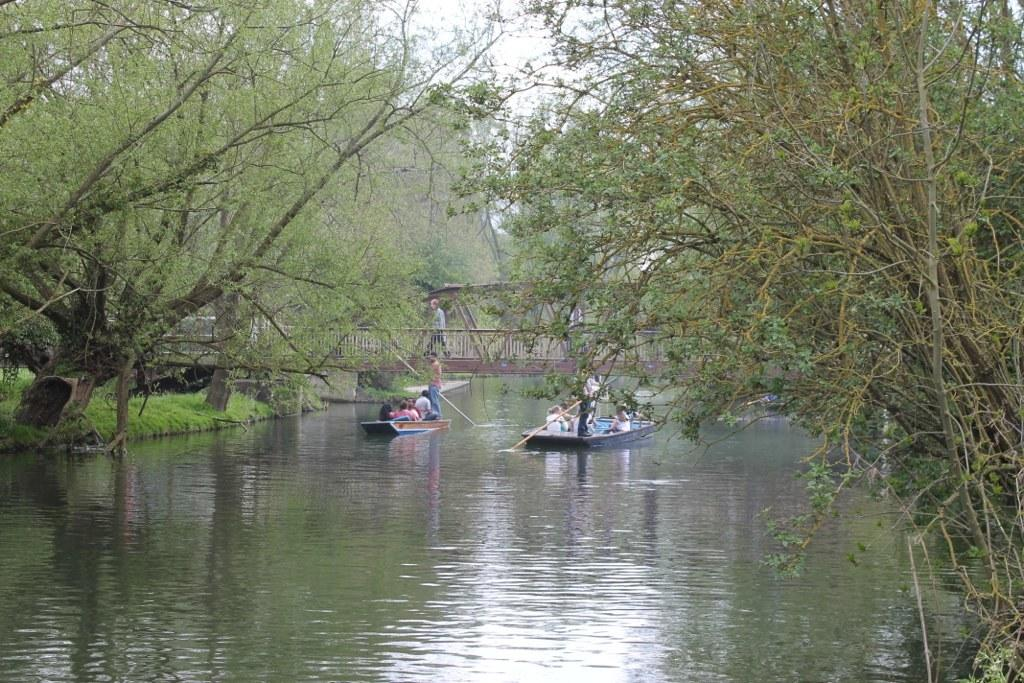What activity are the people engaged in on the water? There are people boating on the surface of the water. What type of vegetation can be seen in the image? Trees are visible in the image. What is the ground cover in the image? Grass is present in the image. What is visible above the water and vegetation? The sky is visible in the image. What is another structure present in the image? There is a person walking on a bridge. What type of engine is powering the boat in the image? There is no information about the engine powering the boat in the image. How many oranges are visible in the image? There are no oranges present in the image. 